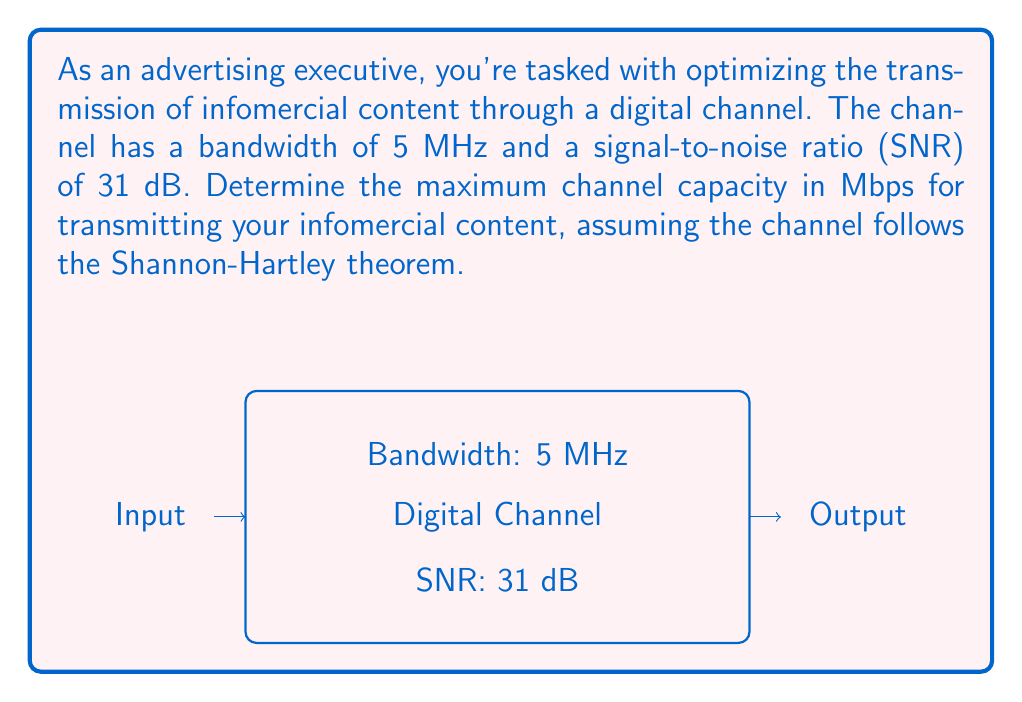Can you answer this question? To solve this problem, we'll use the Shannon-Hartley theorem, which relates channel capacity to bandwidth and signal-to-noise ratio. The steps are as follows:

1) The Shannon-Hartley theorem is given by:
   $$C = B \log_2(1 + SNR)$$
   where $C$ is the channel capacity in bits per second, $B$ is the bandwidth in Hz, and $SNR$ is the linear signal-to-noise ratio.

2) We're given:
   - Bandwidth, $B = 5 \text{ MHz} = 5 \times 10^6 \text{ Hz}$
   - SNR = 31 dB

3) Convert SNR from dB to linear scale:
   $$SNR_{\text{linear}} = 10^{\frac{SNR_{\text{dB}}}{10}} = 10^{\frac{31}{10}} = 1258.93$$

4) Now, let's apply the Shannon-Hartley theorem:
   $$\begin{align}
   C &= (5 \times 10^6) \log_2(1 + 1258.93) \\
   &= 5 \times 10^6 \times \log_2(1259.93) \\
   &= 5 \times 10^6 \times 10.30 \\
   &= 51.5 \times 10^6 \text{ bps}
   \end{align}$$

5) Convert the result to Mbps:
   $$51.5 \times 10^6 \text{ bps} = 51.5 \text{ Mbps}$$

Therefore, the maximum channel capacity for transmitting your infomercial content is approximately 51.5 Mbps.
Answer: 51.5 Mbps 